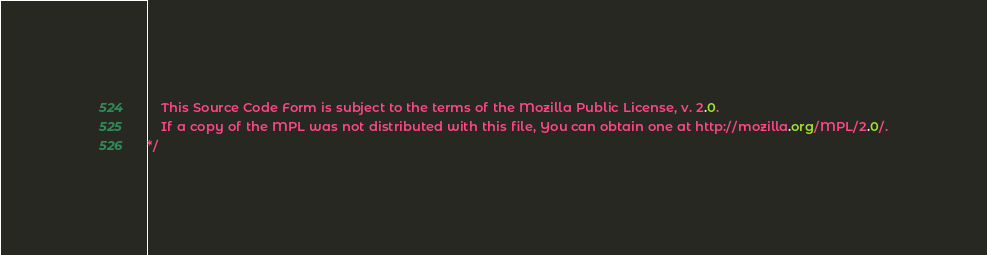Convert code to text. <code><loc_0><loc_0><loc_500><loc_500><_CSS_>    This Source Code Form is subject to the terms of the Mozilla Public License, v. 2.0.
    If a copy of the MPL was not distributed with this file, You can obtain one at http://mozilla.org/MPL/2.0/.
*/</code> 